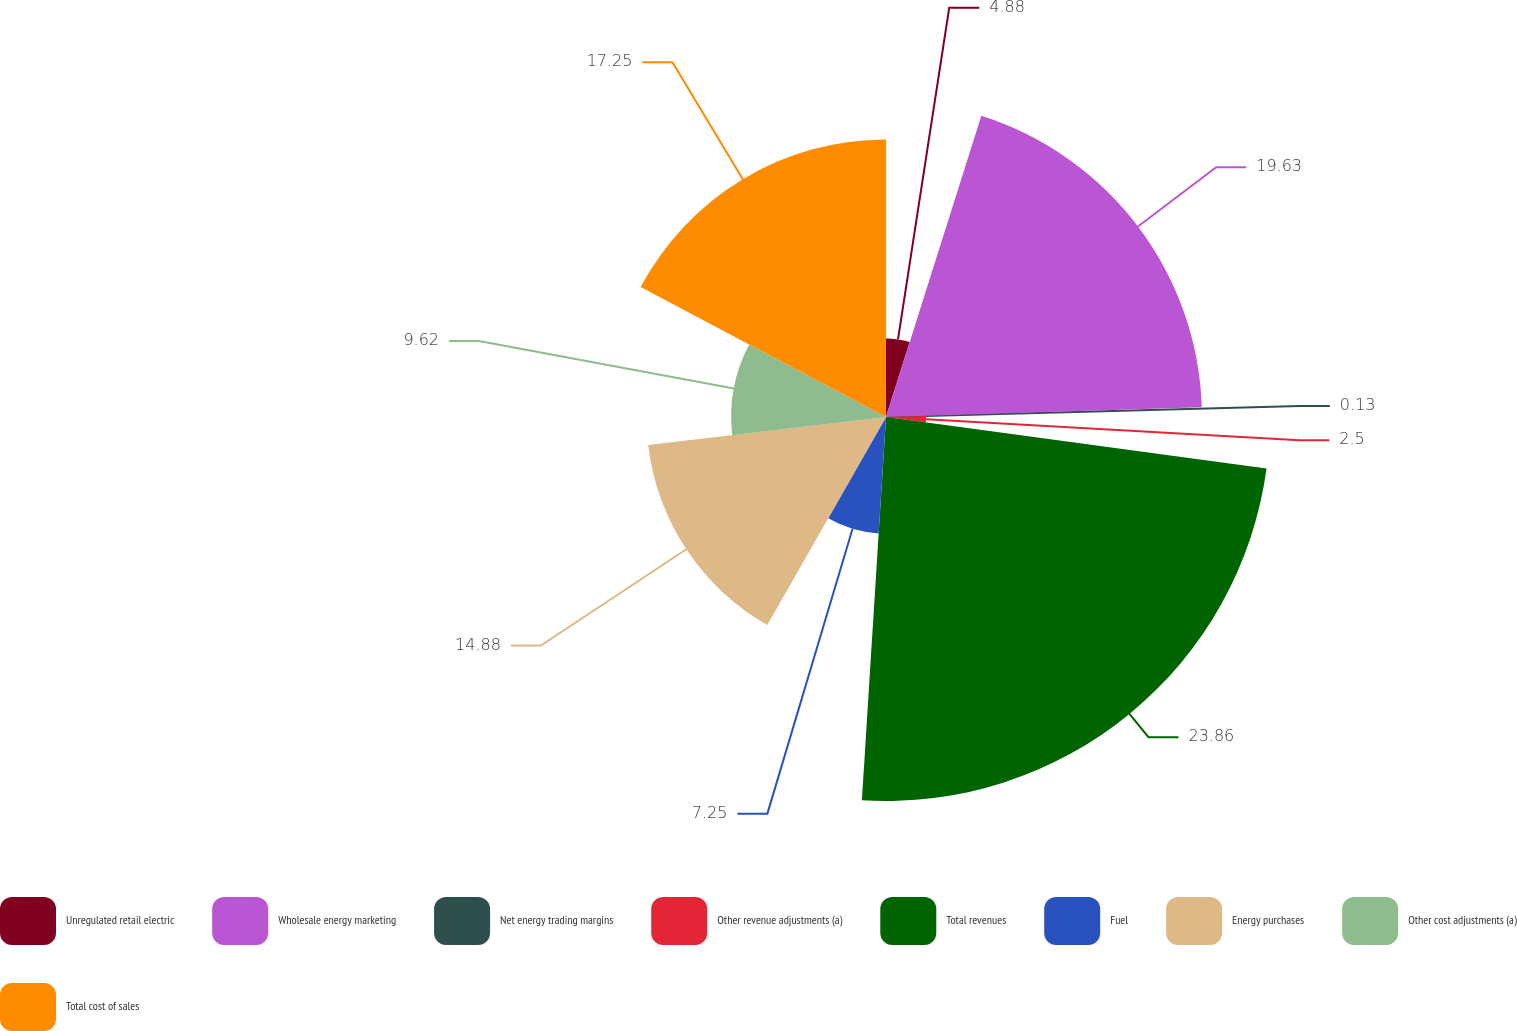Convert chart. <chart><loc_0><loc_0><loc_500><loc_500><pie_chart><fcel>Unregulated retail electric<fcel>Wholesale energy marketing<fcel>Net energy trading margins<fcel>Other revenue adjustments (a)<fcel>Total revenues<fcel>Fuel<fcel>Energy purchases<fcel>Other cost adjustments (a)<fcel>Total cost of sales<nl><fcel>4.88%<fcel>19.63%<fcel>0.13%<fcel>2.5%<fcel>23.86%<fcel>7.25%<fcel>14.88%<fcel>9.62%<fcel>17.25%<nl></chart> 